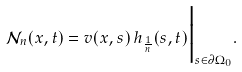Convert formula to latex. <formula><loc_0><loc_0><loc_500><loc_500>\mathcal { N } _ { n } ( x , t ) = v ( x , s ) \, h _ { \frac { 1 } { n } } ( s , t ) \Big | _ { s \in \partial \Omega _ { 0 } } .</formula> 